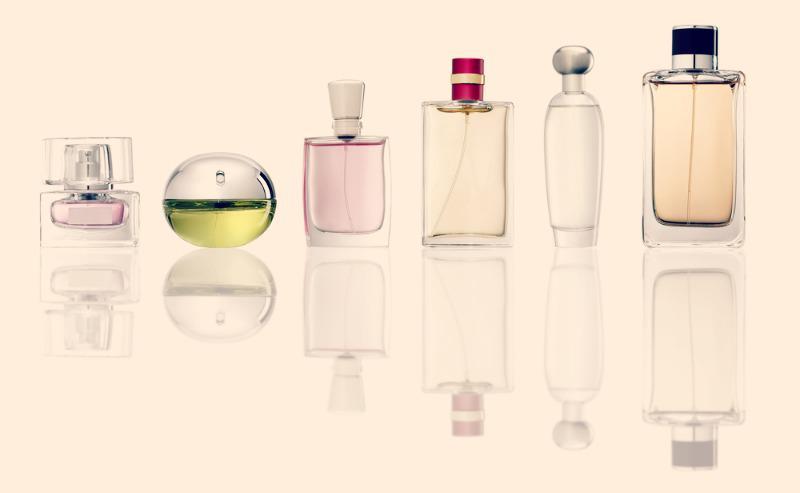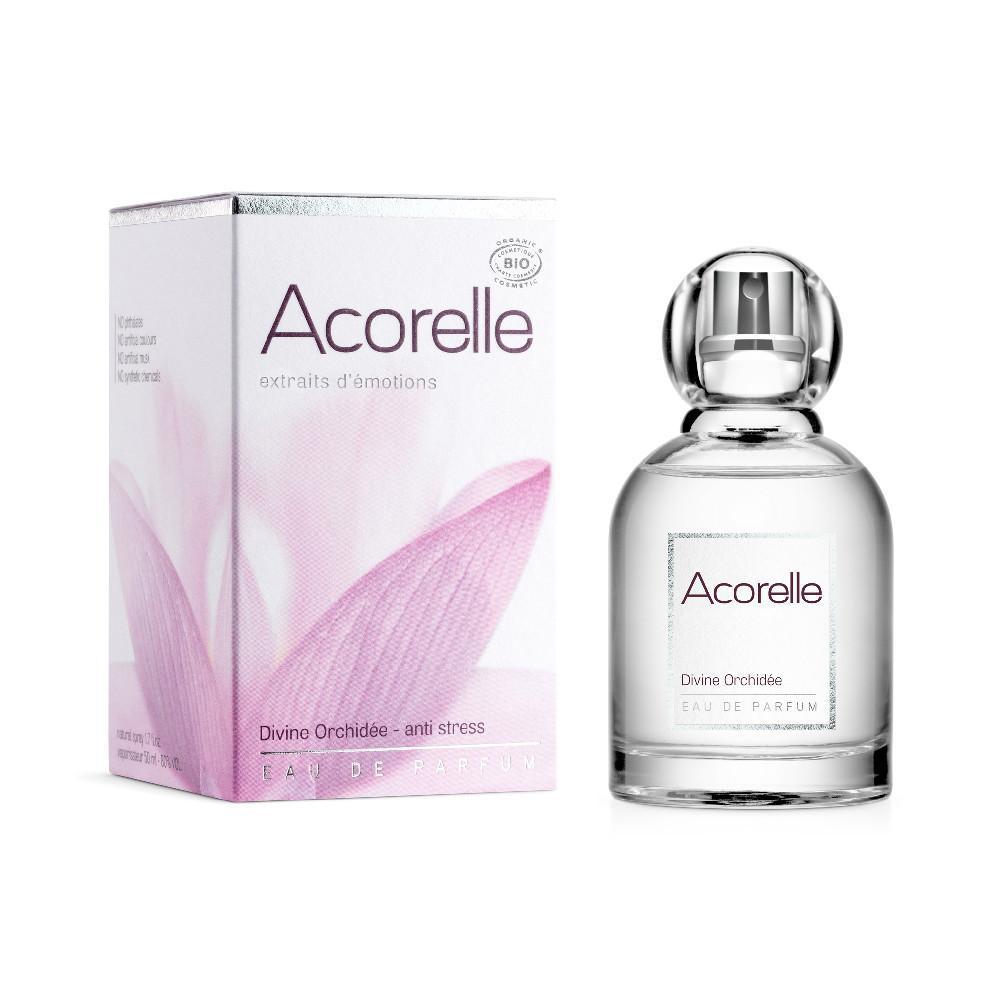The first image is the image on the left, the second image is the image on the right. Given the left and right images, does the statement "There are at least five bottles of perfume with one square bottle that has a red top with a gold stripe." hold true? Answer yes or no. Yes. The first image is the image on the left, the second image is the image on the right. Given the left and right images, does the statement "None of the fragrances are seen with their box." hold true? Answer yes or no. No. 